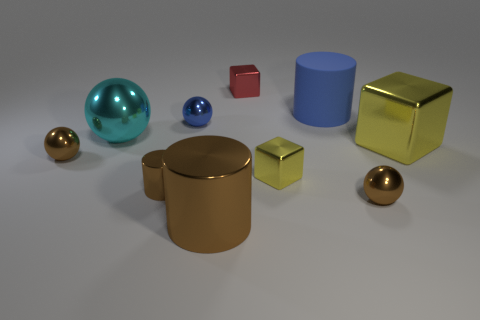What number of things are large cyan metal balls left of the matte thing or blue matte cylinders?
Offer a very short reply. 2. What is the shape of the blue thing to the right of the yellow metallic block that is in front of the large cube?
Offer a terse response. Cylinder. Are there any cyan metal cubes that have the same size as the blue cylinder?
Offer a terse response. No. Is the number of large cylinders greater than the number of brown things?
Your answer should be very brief. No. There is a shiny block that is behind the large sphere; is its size the same as the cyan metal object to the left of the big yellow object?
Make the answer very short. No. How many metal things are both behind the large cube and on the right side of the small metal cylinder?
Your answer should be very brief. 2. There is a large shiny object that is the same shape as the tiny red object; what is its color?
Your answer should be compact. Yellow. Is the number of tiny brown metal things less than the number of tiny things?
Your response must be concise. Yes. Is the size of the rubber cylinder the same as the shiny block on the right side of the blue matte cylinder?
Offer a very short reply. Yes. What is the color of the metallic thing in front of the brown object on the right side of the small red object?
Keep it short and to the point. Brown. 